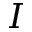Convert formula to latex. <formula><loc_0><loc_0><loc_500><loc_500>I</formula> 